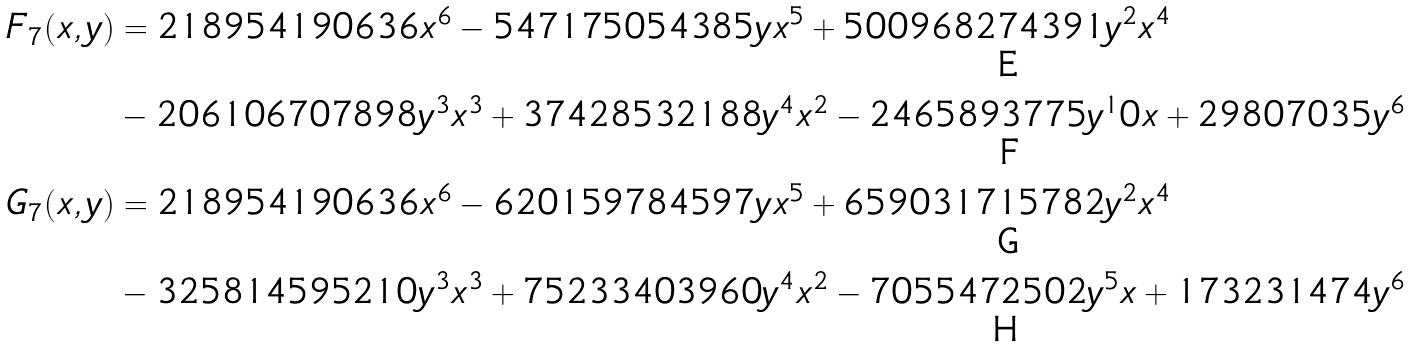<formula> <loc_0><loc_0><loc_500><loc_500>F _ { 7 } ( x , y ) & = 2 1 8 9 5 4 1 9 0 6 3 6 x ^ { 6 } - 5 4 7 1 7 5 0 5 4 3 8 5 y x ^ { 5 } + 5 0 0 9 6 8 2 7 4 3 9 1 y ^ { 2 } x ^ { 4 } \\ & - 2 0 6 1 0 6 7 0 7 8 9 8 y ^ { 3 } x ^ { 3 } + 3 7 4 2 8 5 3 2 1 8 8 y ^ { 4 } x ^ { 2 } - 2 4 6 5 8 9 3 7 7 5 y ^ { 1 } 0 x + 2 9 8 0 7 0 3 5 y ^ { 6 } \\ G _ { 7 } ( x , y ) & = 2 1 8 9 5 4 1 9 0 6 3 6 x ^ { 6 } - 6 2 0 1 5 9 7 8 4 5 9 7 y x ^ { 5 } + 6 5 9 0 3 1 7 1 5 7 8 2 y ^ { 2 } x ^ { 4 } \\ & - 3 2 5 8 1 4 5 9 5 2 1 0 y ^ { 3 } x ^ { 3 } + 7 5 2 3 3 4 0 3 9 6 0 y ^ { 4 } x ^ { 2 } - 7 0 5 5 4 7 2 5 0 2 y ^ { 5 } x + 1 7 3 2 3 1 4 7 4 y ^ { 6 }</formula> 